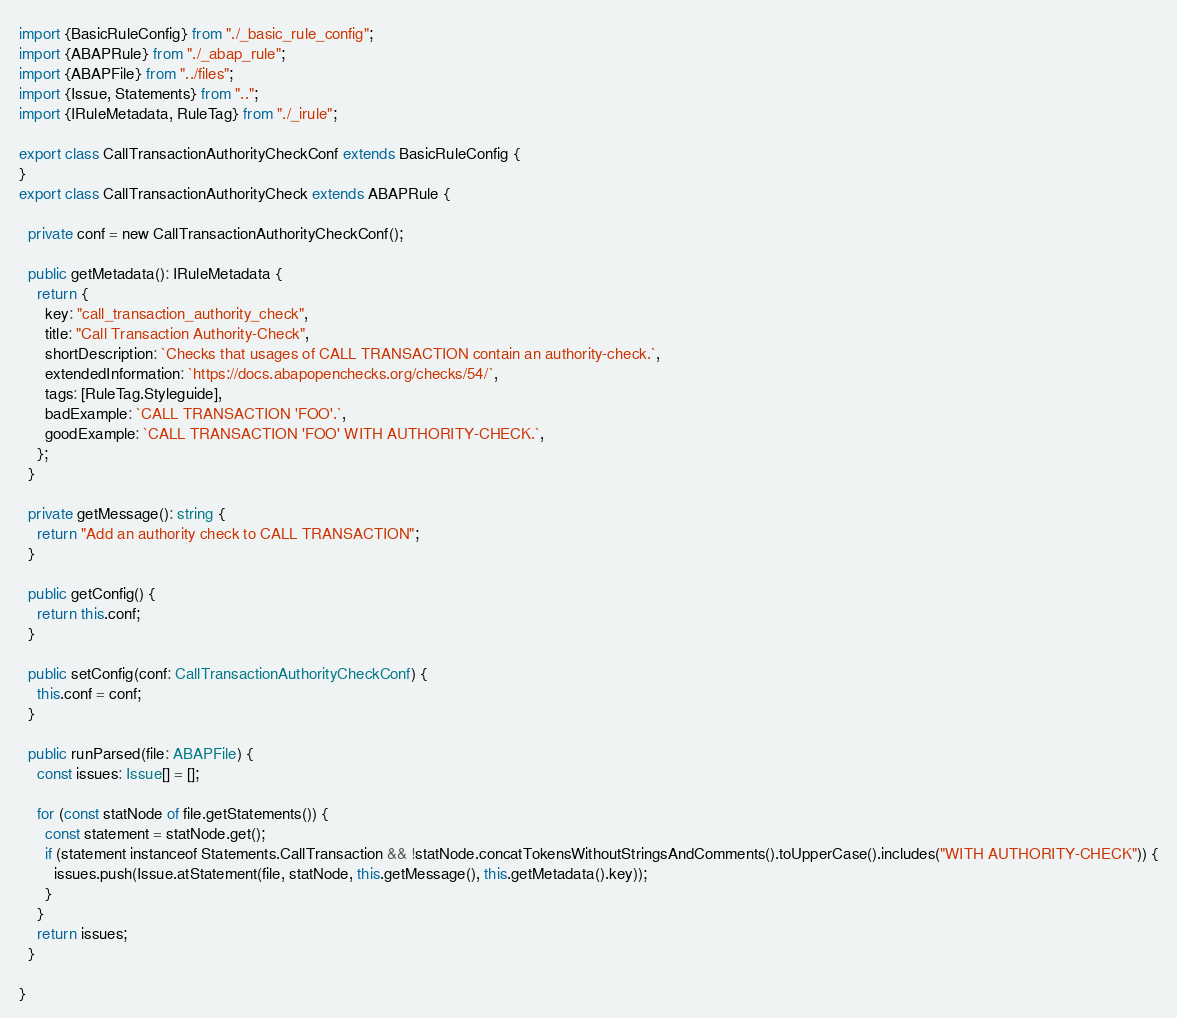<code> <loc_0><loc_0><loc_500><loc_500><_TypeScript_>import {BasicRuleConfig} from "./_basic_rule_config";
import {ABAPRule} from "./_abap_rule";
import {ABAPFile} from "../files";
import {Issue, Statements} from "..";
import {IRuleMetadata, RuleTag} from "./_irule";

export class CallTransactionAuthorityCheckConf extends BasicRuleConfig {
}
export class CallTransactionAuthorityCheck extends ABAPRule {

  private conf = new CallTransactionAuthorityCheckConf();

  public getMetadata(): IRuleMetadata {
    return {
      key: "call_transaction_authority_check",
      title: "Call Transaction Authority-Check",
      shortDescription: `Checks that usages of CALL TRANSACTION contain an authority-check.`,
      extendedInformation: `https://docs.abapopenchecks.org/checks/54/`,
      tags: [RuleTag.Styleguide],
      badExample: `CALL TRANSACTION 'FOO'.`,
      goodExample: `CALL TRANSACTION 'FOO' WITH AUTHORITY-CHECK.`,
    };
  }

  private getMessage(): string {
    return "Add an authority check to CALL TRANSACTION";
  }

  public getConfig() {
    return this.conf;
  }

  public setConfig(conf: CallTransactionAuthorityCheckConf) {
    this.conf = conf;
  }

  public runParsed(file: ABAPFile) {
    const issues: Issue[] = [];

    for (const statNode of file.getStatements()) {
      const statement = statNode.get();
      if (statement instanceof Statements.CallTransaction && !statNode.concatTokensWithoutStringsAndComments().toUpperCase().includes("WITH AUTHORITY-CHECK")) {
        issues.push(Issue.atStatement(file, statNode, this.getMessage(), this.getMetadata().key));
      }
    }
    return issues;
  }

}</code> 